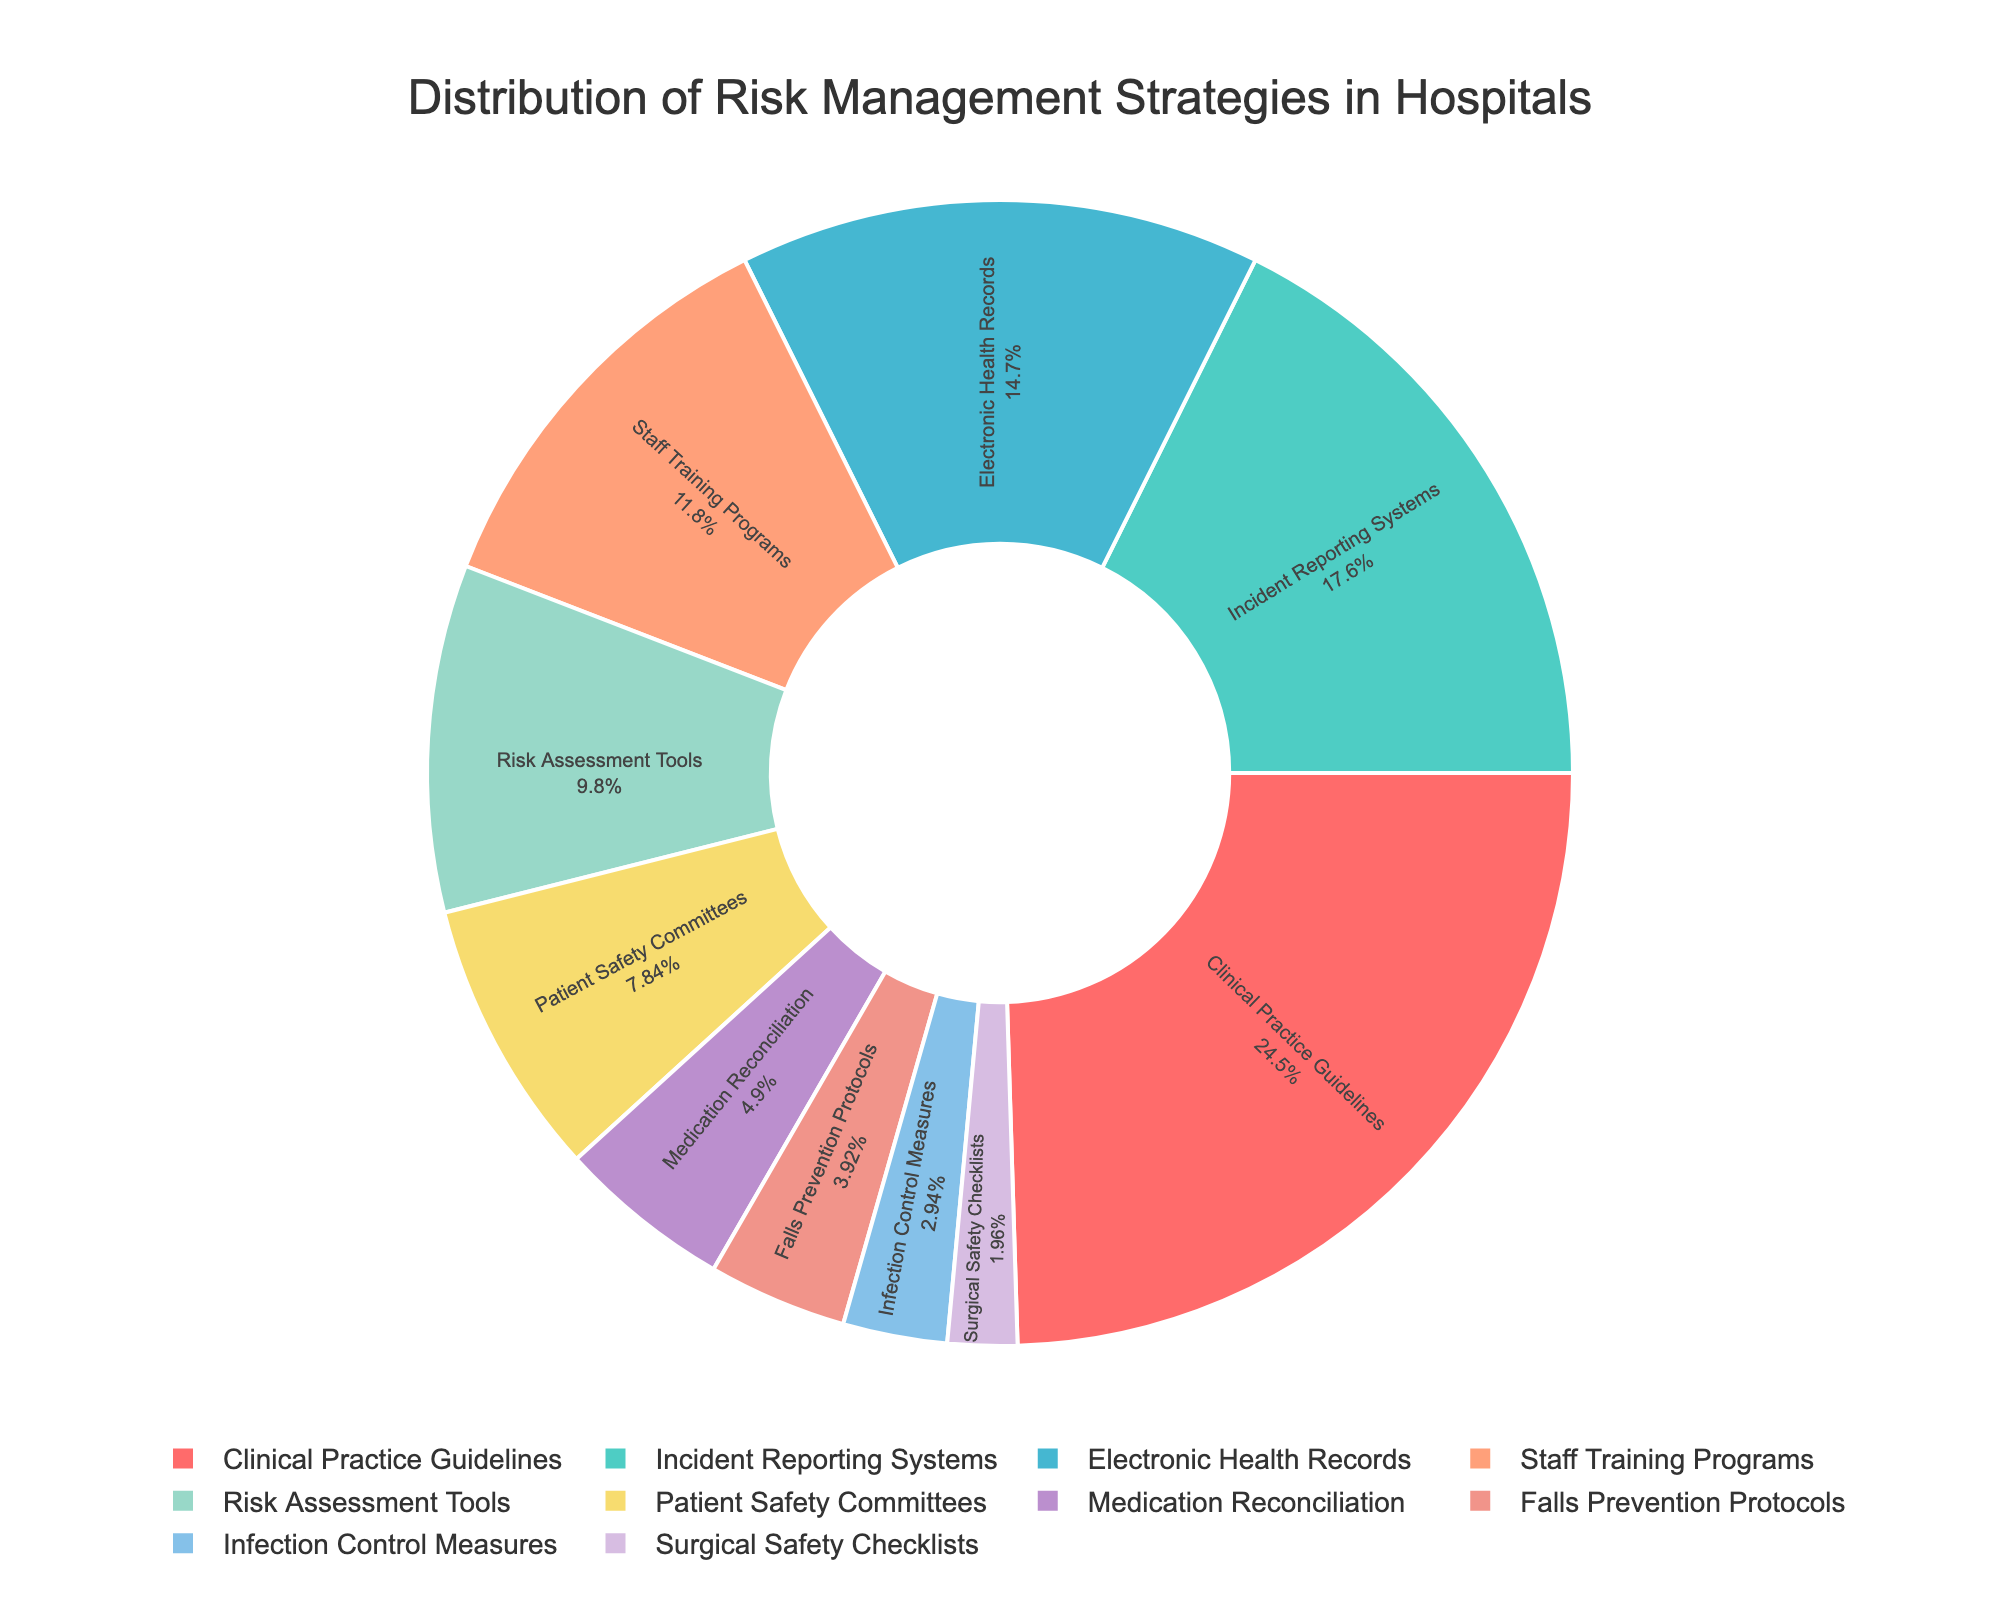What is the percentage of hospitals using Clinical Practice Guidelines? Look at the segment labeled "Clinical Practice Guidelines" in the pie chart and read the percentage value inside or next to it.
Answer: 25% Which risk management strategy is the second most implemented in hospitals? Identify the segment with the second-largest area or read the percentages. The "Incident Reporting Systems" segment has the second highest percentage.
Answer: Incident Reporting Systems What is the combined percentage of hospitals using Medication Reconciliation and Infection Control Measures? Find and add the percentage values for "Medication Reconciliation" and "Infection Control Measures". This is 5% + 3%.
Answer: 8% How does the implementation of Electronic Health Records compare to Staff Training Programs? Compare the percentages for "Electronic Health Records" and "Staff Training Programs". "Electronic Health Records" has 15%, and "Staff Training Programs" has 12%.
Answer: Higher Which risk management strategies have a combined percentage of more than 50%? Identify and add the percentages of the top segments until they sum to more than 50%. Adding "Clinical Practice Guidelines" (25%), "Incident Reporting Systems" (18%), and "Electronic Health Records" (15%) results in 58%.
Answer: Clinical Practice Guidelines, Incident Reporting Systems, Electronic Health Records What percentage of the strategies are implemented by less than 5% of hospitals? Identify segments with percentages less than 5% and sum them up. "Falls Prevention Protocols" (4%), "Infection Control Measures" (3%), and "Surgical Safety Checklists" (2%) are identified. Adding them gives 4% + 3% + 2%.
Answer: 9% Are there more hospitals implementing Patient Safety Committees or Risk Assessment Tools? Compare the percentages for "Patient Safety Committees" (8%) and "Risk Assessment Tools" (10%).
Answer: Risk Assessment Tools Which strategy is implemented by the fewest hospitals? Identify the segment with the smallest percentage in the pie chart. The segment labeled "Surgical Safety Checklists" has the smallest percentage.
Answer: Surgical Safety Checklists What is the percentage difference between the most and least implemented strategies? Subtract the smallest percentage (Surgical Safety Checklists, 2%) from the largest percentage (Clinical Practice Guidelines, 25%).
Answer: 23% What percentage of hospitals implement either Staff Training Programs or Falls Prevention Protocols? Add the percentage values for "Staff Training Programs" (12%) and "Falls Prevention Protocols" (4%).
Answer: 16% 